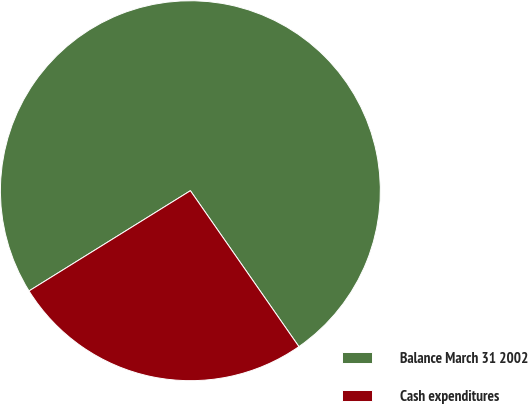Convert chart. <chart><loc_0><loc_0><loc_500><loc_500><pie_chart><fcel>Balance March 31 2002<fcel>Cash expenditures<nl><fcel>74.17%<fcel>25.83%<nl></chart> 